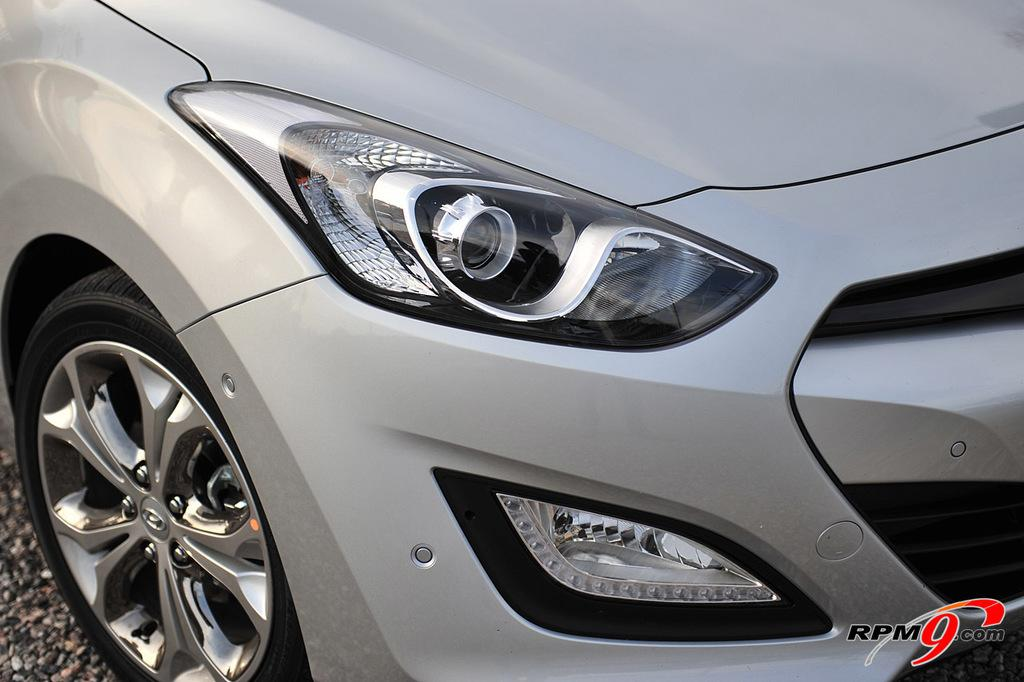What is the main subject of the image? The main subject of the image is a car. What are the car's main features? The car has wheels and headlights. Is there any text present in the image? Yes, there is text in the bottom right corner of the image. What type of smoke is coming out of the car's exhaust in the image? There is no smoke coming out of the car's exhaust in the image, as the car is not in motion. What kind of shade is covering the car in the image? There is no shade covering the car in the image; it is fully visible. 